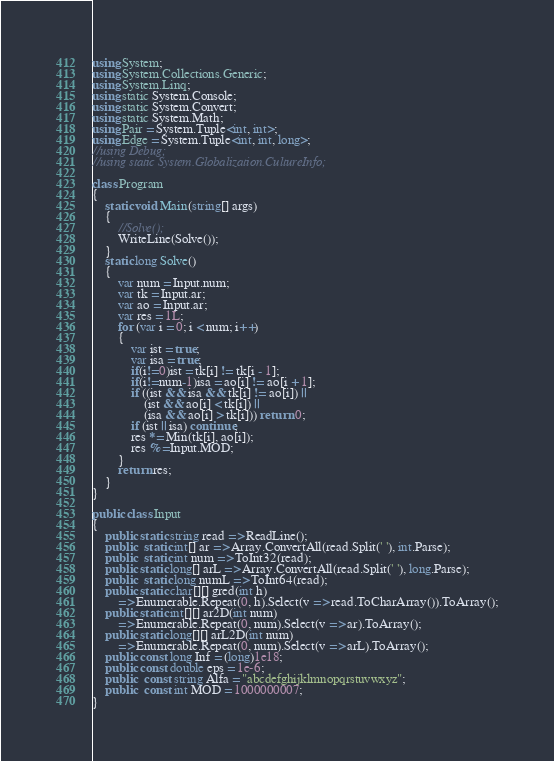<code> <loc_0><loc_0><loc_500><loc_500><_C#_>using System;
using System.Collections.Generic;
using System.Linq;
using static System.Console;
using static System.Convert;
using static System.Math;
using Pair = System.Tuple<int, int>;
using Edge = System.Tuple<int, int, long>;
//using Debug;
//using static System.Globalization.CultureInfo;

class Program
{
    static void Main(string[] args)
    {
        //Solve();
        WriteLine(Solve());
    }
    static long Solve()
    {
        var num = Input.num;
        var tk = Input.ar;
        var ao = Input.ar;
        var res = 1L;
        for (var i = 0; i < num; i++)
        {
            var ist = true;
            var isa = true;
            if(i!=0)ist = tk[i] != tk[i - 1];
            if(i!=num-1)isa = ao[i] != ao[i + 1];
            if ((ist && isa && tk[i] != ao[i]) ||
                (ist && ao[i] < tk[i]) ||
                (isa && ao[i] > tk[i])) return 0;
            if (ist || isa) continue;
            res *= Min(tk[i], ao[i]);
            res %= Input.MOD;
        }
        return res;
    }
}

public class Input
{
    public static string read => ReadLine();
    public  static int[] ar => Array.ConvertAll(read.Split(' '), int.Parse);
    public  static int num => ToInt32(read);
    public static long[] arL => Array.ConvertAll(read.Split(' '), long.Parse);
    public  static long numL => ToInt64(read);
    public static char[][] gred(int h) 
        => Enumerable.Repeat(0, h).Select(v => read.ToCharArray()).ToArray();
    public static int[][] ar2D(int num)
        => Enumerable.Repeat(0, num).Select(v => ar).ToArray();
    public static long[][] arL2D(int num)
        => Enumerable.Repeat(0, num).Select(v => arL).ToArray();
    public const long Inf = (long)1e18;
    public const double eps = 1e-6;
    public  const string Alfa = "abcdefghijklmnopqrstuvwxyz";
    public  const int MOD = 1000000007;
}
</code> 